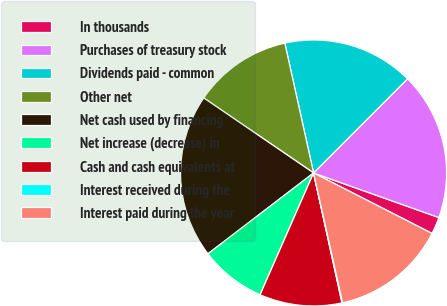<chart> <loc_0><loc_0><loc_500><loc_500><pie_chart><fcel>In thousands<fcel>Purchases of treasury stock<fcel>Dividends paid - common<fcel>Other net<fcel>Net cash used by financing<fcel>Net increase (decrease) in<fcel>Cash and cash equivalents at<fcel>Interest received during the<fcel>Interest paid during the year<nl><fcel>2.07%<fcel>17.95%<fcel>15.96%<fcel>11.99%<fcel>19.93%<fcel>8.02%<fcel>10.01%<fcel>0.08%<fcel>13.98%<nl></chart> 